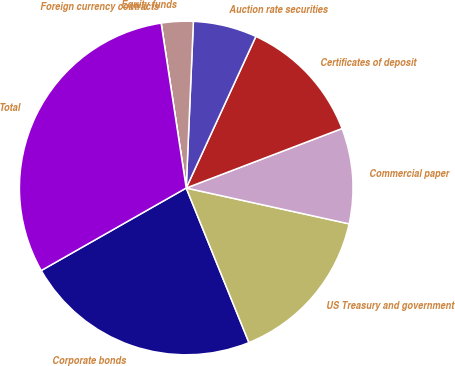Convert chart. <chart><loc_0><loc_0><loc_500><loc_500><pie_chart><fcel>Corporate bonds<fcel>US Treasury and government<fcel>Commercial paper<fcel>Certificates of deposit<fcel>Auction rate securities<fcel>Equity funds<fcel>Foreign currency contracts<fcel>Total<nl><fcel>22.9%<fcel>15.42%<fcel>9.25%<fcel>12.34%<fcel>6.17%<fcel>3.09%<fcel>0.0%<fcel>30.83%<nl></chart> 